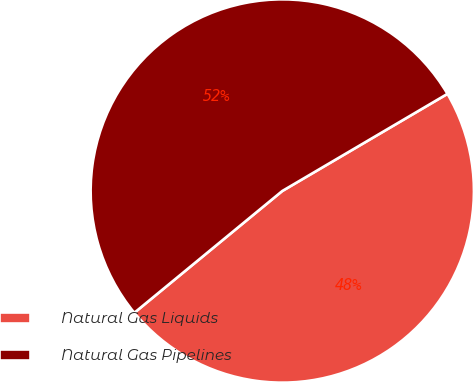Convert chart. <chart><loc_0><loc_0><loc_500><loc_500><pie_chart><fcel>Natural Gas Liquids<fcel>Natural Gas Pipelines<nl><fcel>47.5%<fcel>52.5%<nl></chart> 